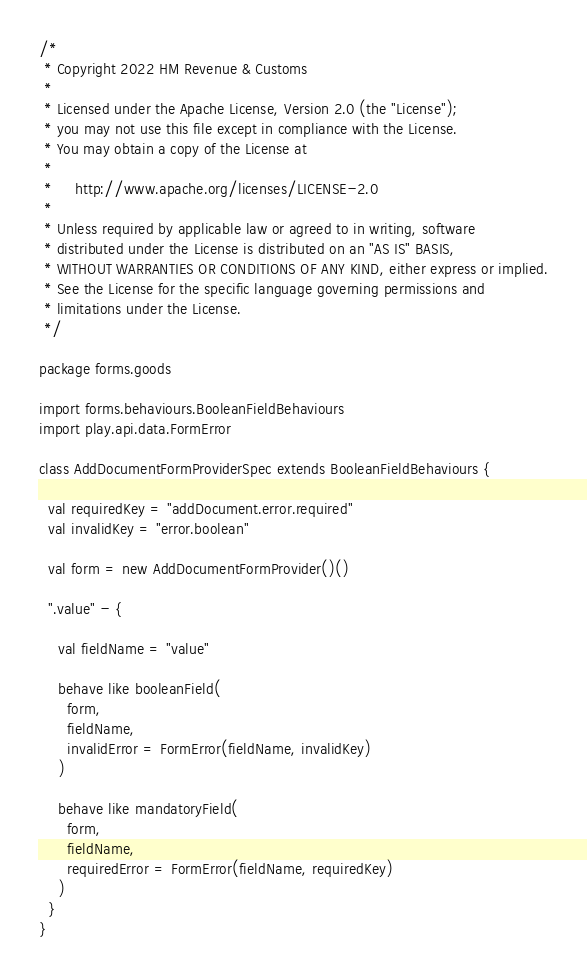Convert code to text. <code><loc_0><loc_0><loc_500><loc_500><_Scala_>/*
 * Copyright 2022 HM Revenue & Customs
 *
 * Licensed under the Apache License, Version 2.0 (the "License");
 * you may not use this file except in compliance with the License.
 * You may obtain a copy of the License at
 *
 *     http://www.apache.org/licenses/LICENSE-2.0
 *
 * Unless required by applicable law or agreed to in writing, software
 * distributed under the License is distributed on an "AS IS" BASIS,
 * WITHOUT WARRANTIES OR CONDITIONS OF ANY KIND, either express or implied.
 * See the License for the specific language governing permissions and
 * limitations under the License.
 */

package forms.goods

import forms.behaviours.BooleanFieldBehaviours
import play.api.data.FormError

class AddDocumentFormProviderSpec extends BooleanFieldBehaviours {

  val requiredKey = "addDocument.error.required"
  val invalidKey = "error.boolean"

  val form = new AddDocumentFormProvider()()

  ".value" - {

    val fieldName = "value"

    behave like booleanField(
      form,
      fieldName,
      invalidError = FormError(fieldName, invalidKey)
    )

    behave like mandatoryField(
      form,
      fieldName,
      requiredError = FormError(fieldName, requiredKey)
    )
  }
}
</code> 